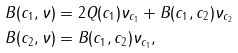Convert formula to latex. <formula><loc_0><loc_0><loc_500><loc_500>B ( c _ { 1 } , \nu ) & = 2 Q ( c _ { 1 } ) \nu _ { c _ { 1 } } + B ( c _ { 1 } , c _ { 2 } ) \nu _ { c _ { 2 } } \\ B ( c _ { 2 } , \nu ) & = B ( c _ { 1 } , c _ { 2 } ) \nu _ { c _ { 1 } } ,</formula> 